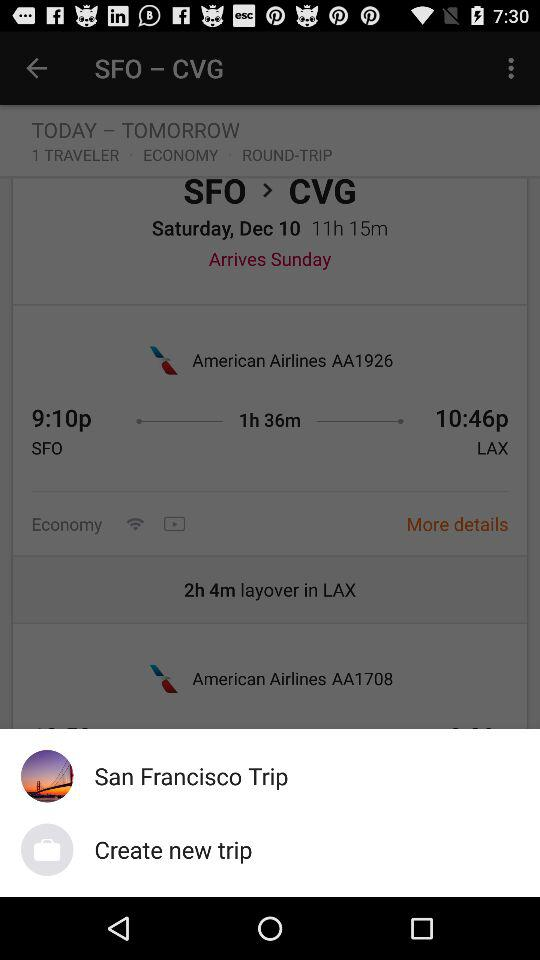What is the airline's name? The name is American Airlines AA1926. 